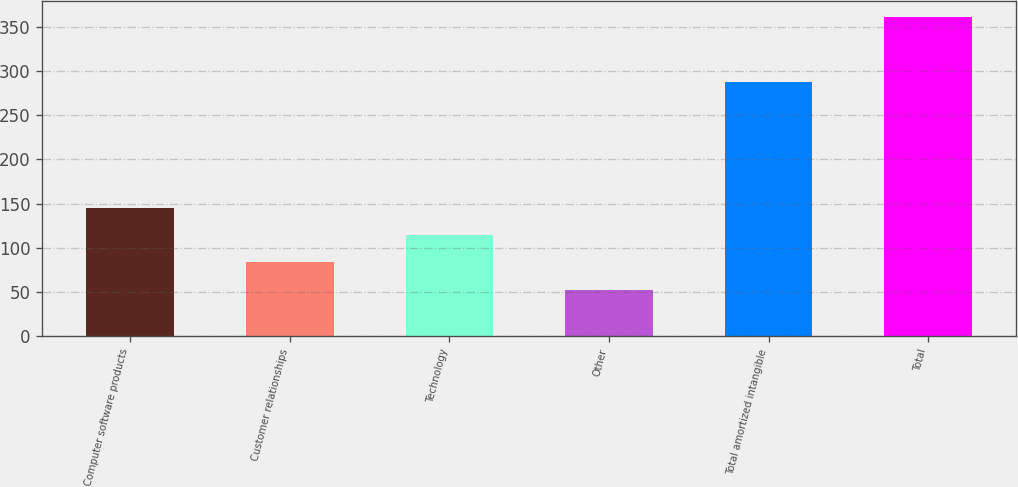<chart> <loc_0><loc_0><loc_500><loc_500><bar_chart><fcel>Computer software products<fcel>Customer relationships<fcel>Technology<fcel>Other<fcel>Total amortized intangible<fcel>Total<nl><fcel>145.09<fcel>83.43<fcel>114.26<fcel>52.6<fcel>287.2<fcel>360.9<nl></chart> 